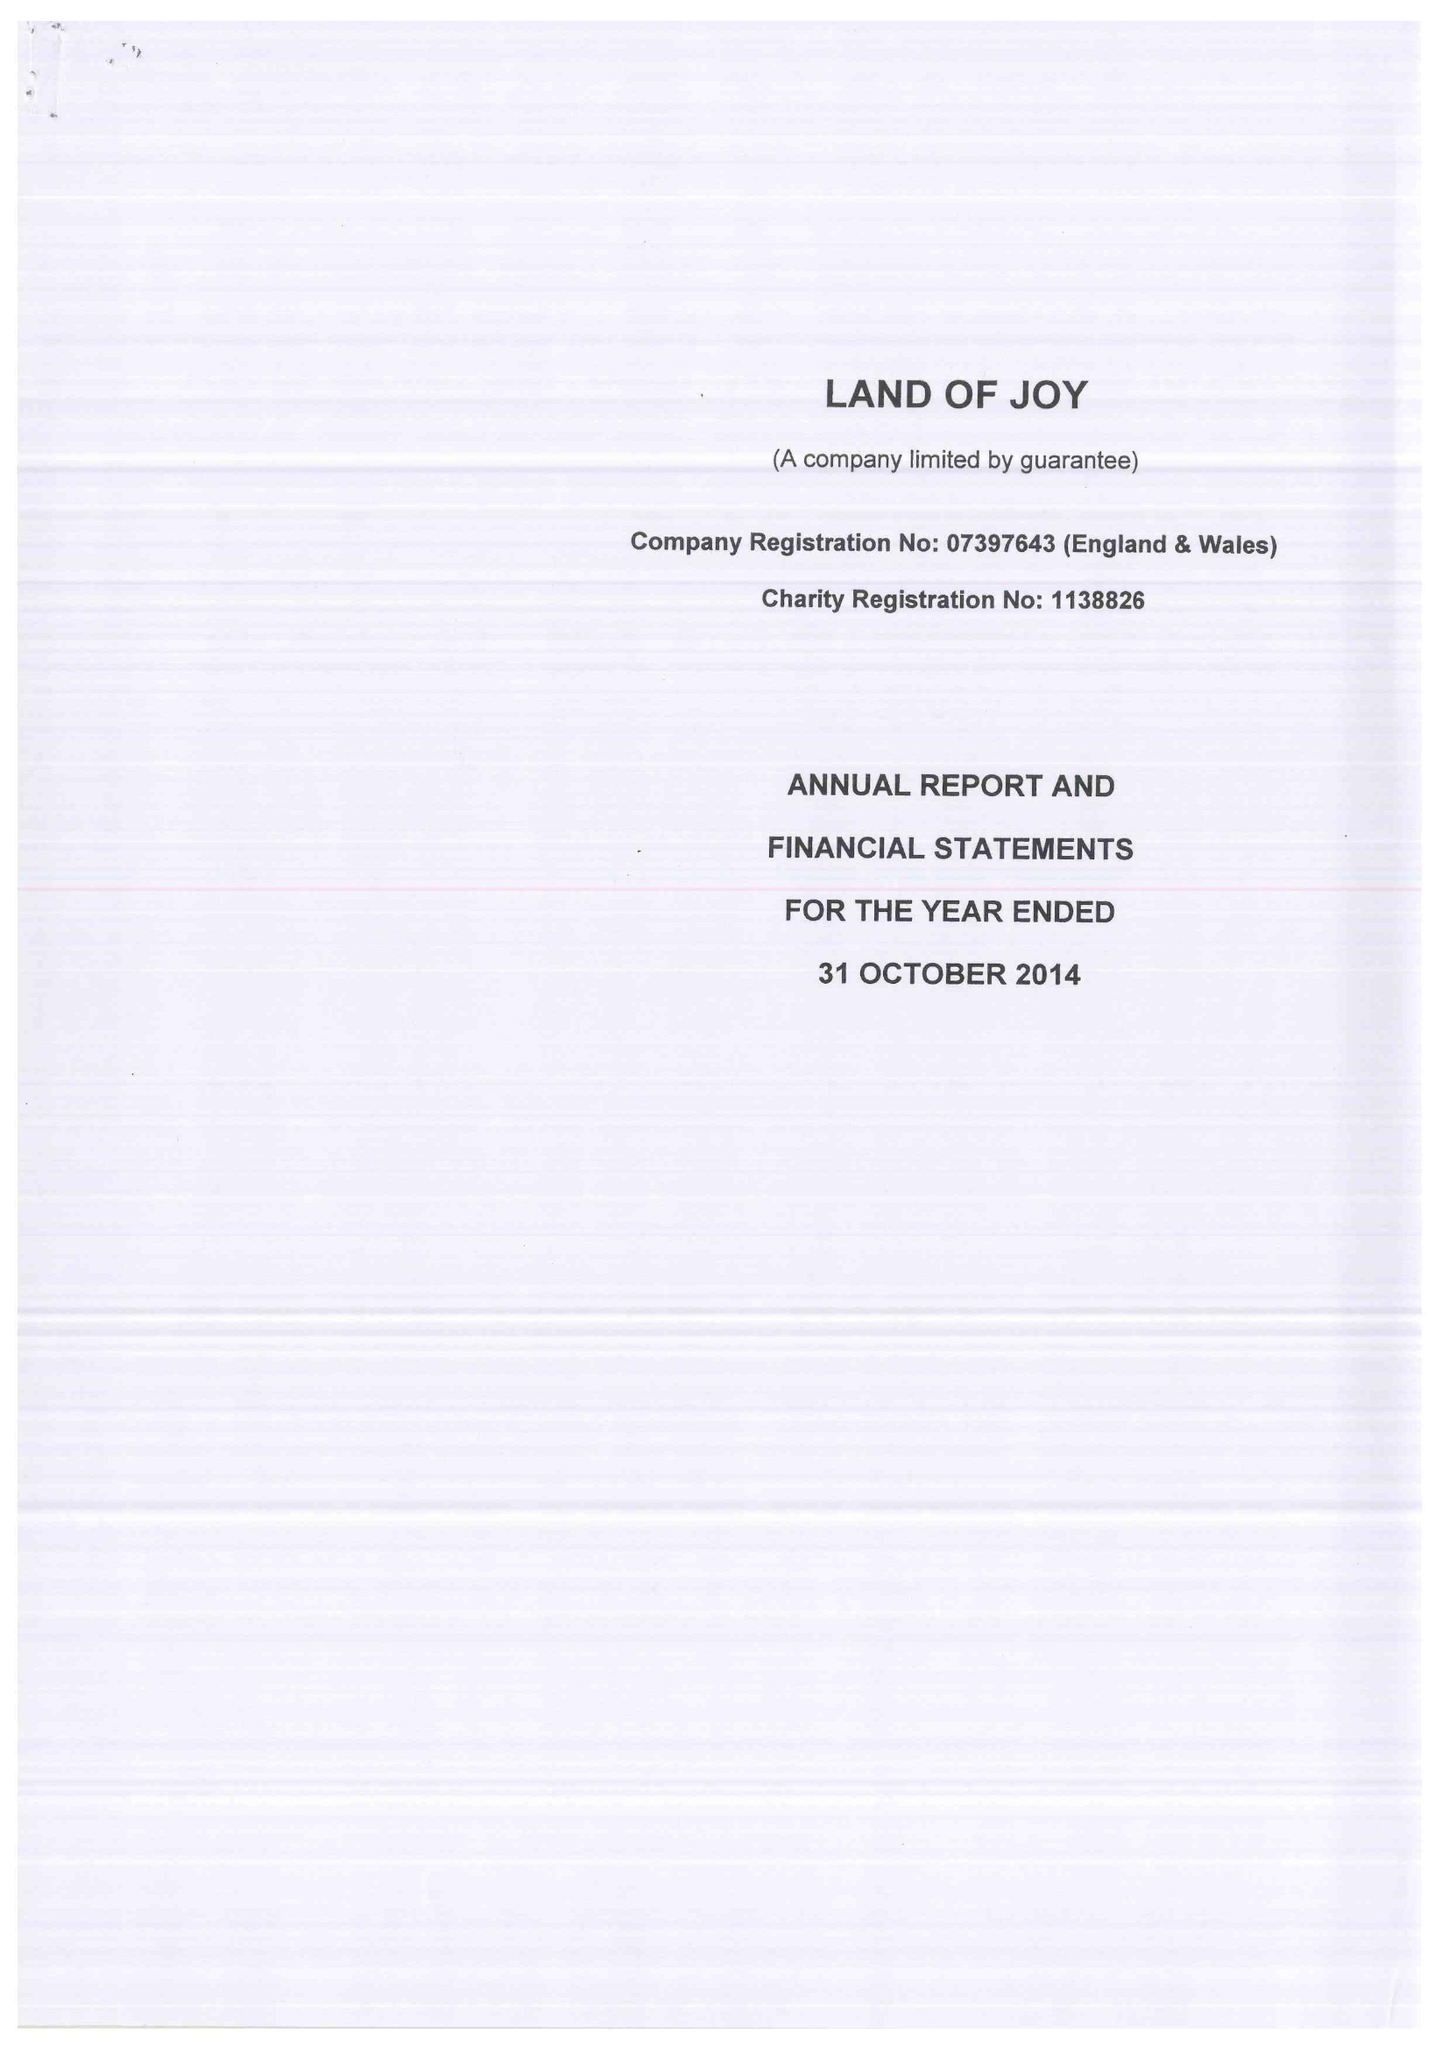What is the value for the address__street_line?
Answer the question using a single word or phrase. GREENHAUGH 